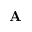<formula> <loc_0><loc_0><loc_500><loc_500>\mathbf A</formula> 